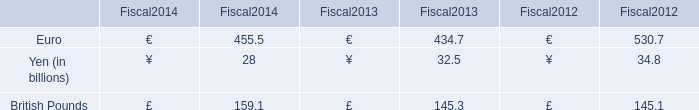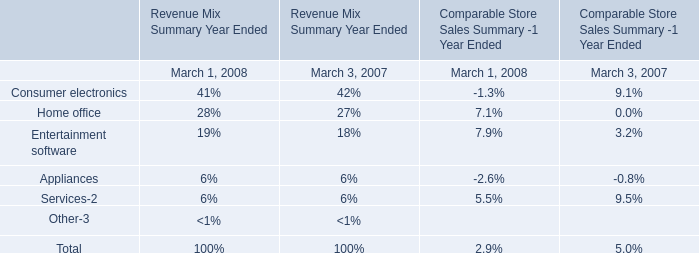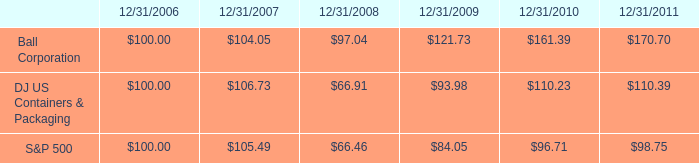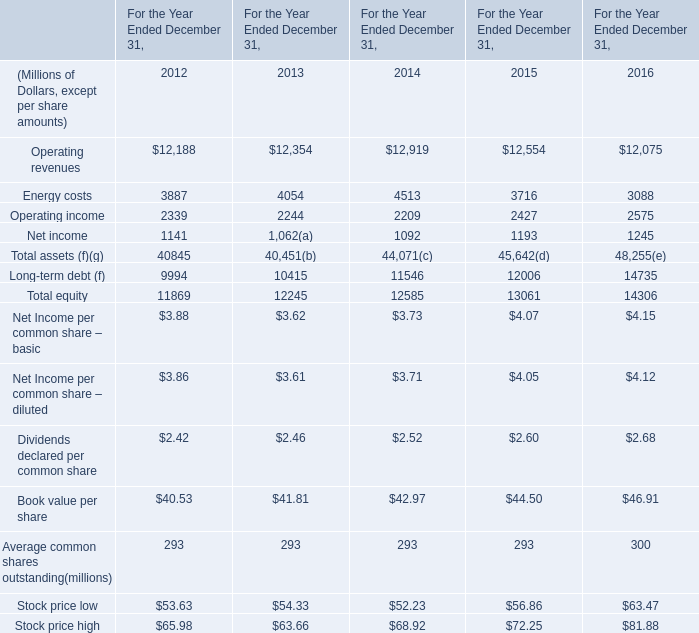In the year/section with the most Energy costs, what is the growth rate of Total equity? 
Computations: ((12245 - 12585) / 12245)
Answer: -0.02777. 